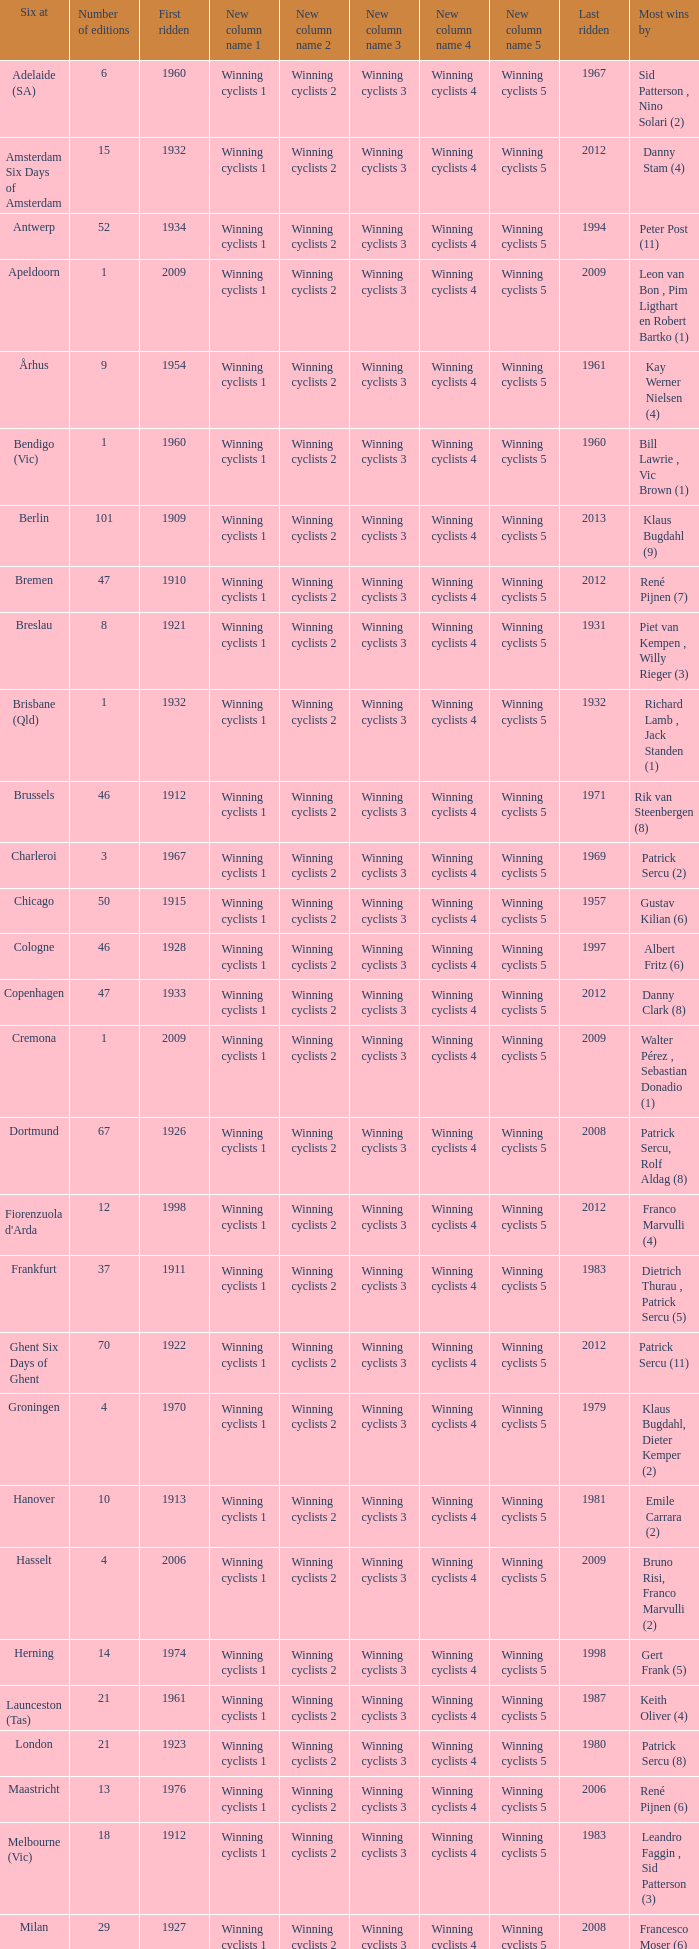How many editions have a most wins value of Franco Marvulli (4)? 1.0. 